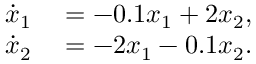Convert formula to latex. <formula><loc_0><loc_0><loc_500><loc_500>\begin{array} { r l } { \dot { x } _ { 1 } } & = - 0 . 1 x _ { 1 } + 2 x _ { 2 } , } \\ { \dot { x } _ { 2 } } & = - 2 x _ { 1 } - 0 . 1 x _ { 2 } . } \end{array}</formula> 